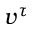<formula> <loc_0><loc_0><loc_500><loc_500>v ^ { \tau }</formula> 